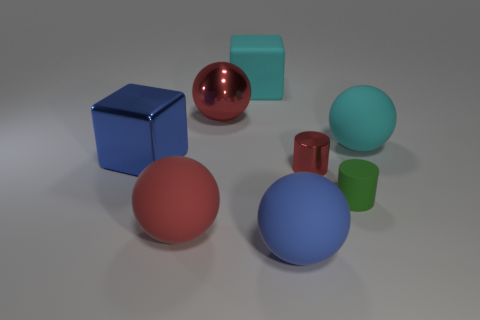There is a metal ball on the left side of the big cyan matte thing that is in front of the big red sphere behind the large blue shiny object; what is its size? The metal ball to the left of the large cyan block appears to be of a medium size relative to the objects in the image, particularly when compared to the prominent big red sphere and the large blue shiny cube. 